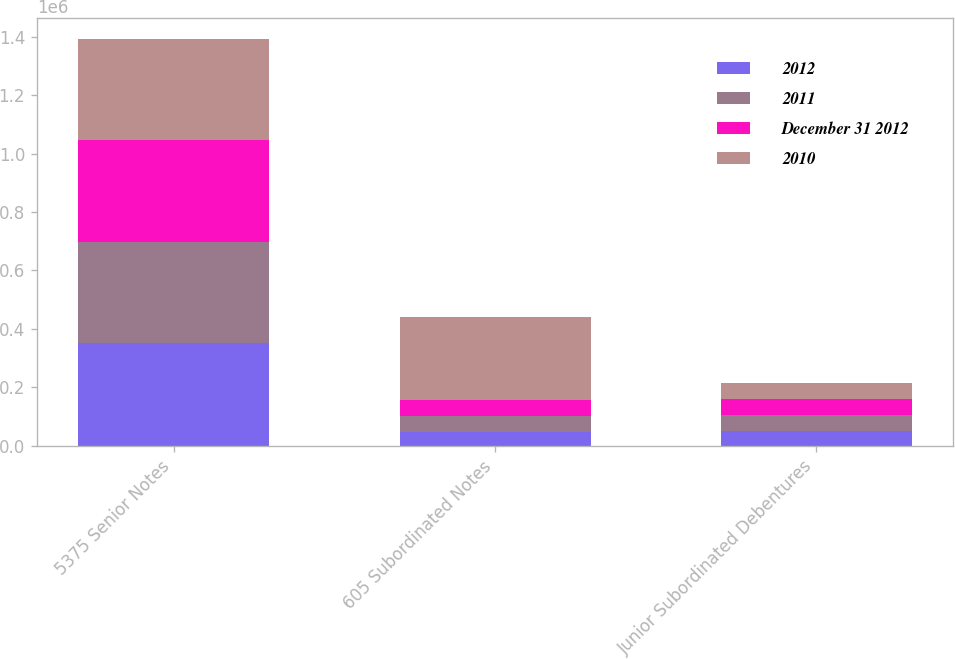Convert chart to OTSL. <chart><loc_0><loc_0><loc_500><loc_500><stacked_bar_chart><ecel><fcel>5375 Senior Notes<fcel>605 Subordinated Notes<fcel>Junior Subordinated Debentures<nl><fcel>2012<fcel>350000<fcel>45964<fcel>50000<nl><fcel>2011<fcel>347995<fcel>54571<fcel>55196<nl><fcel>December 31 2012<fcel>347793<fcel>55075<fcel>55372<nl><fcel>2010<fcel>347601<fcel>285937<fcel>55548<nl></chart> 